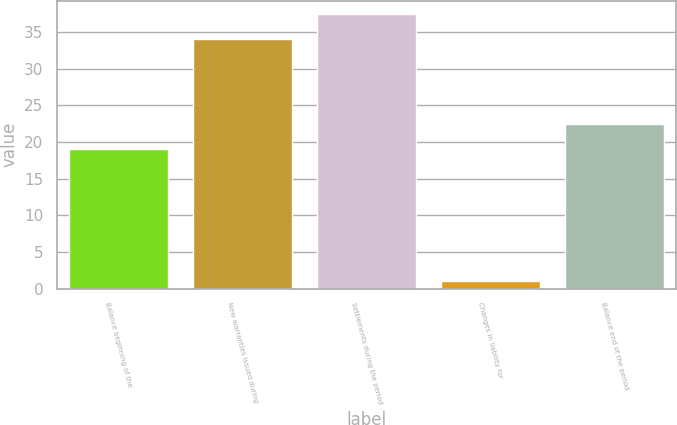<chart> <loc_0><loc_0><loc_500><loc_500><bar_chart><fcel>Balance beginning of the<fcel>New warranties issued during<fcel>Settlements during the period<fcel>Changes in liability for<fcel>Balance end of the period<nl><fcel>19<fcel>34<fcel>37.4<fcel>1<fcel>22.4<nl></chart> 